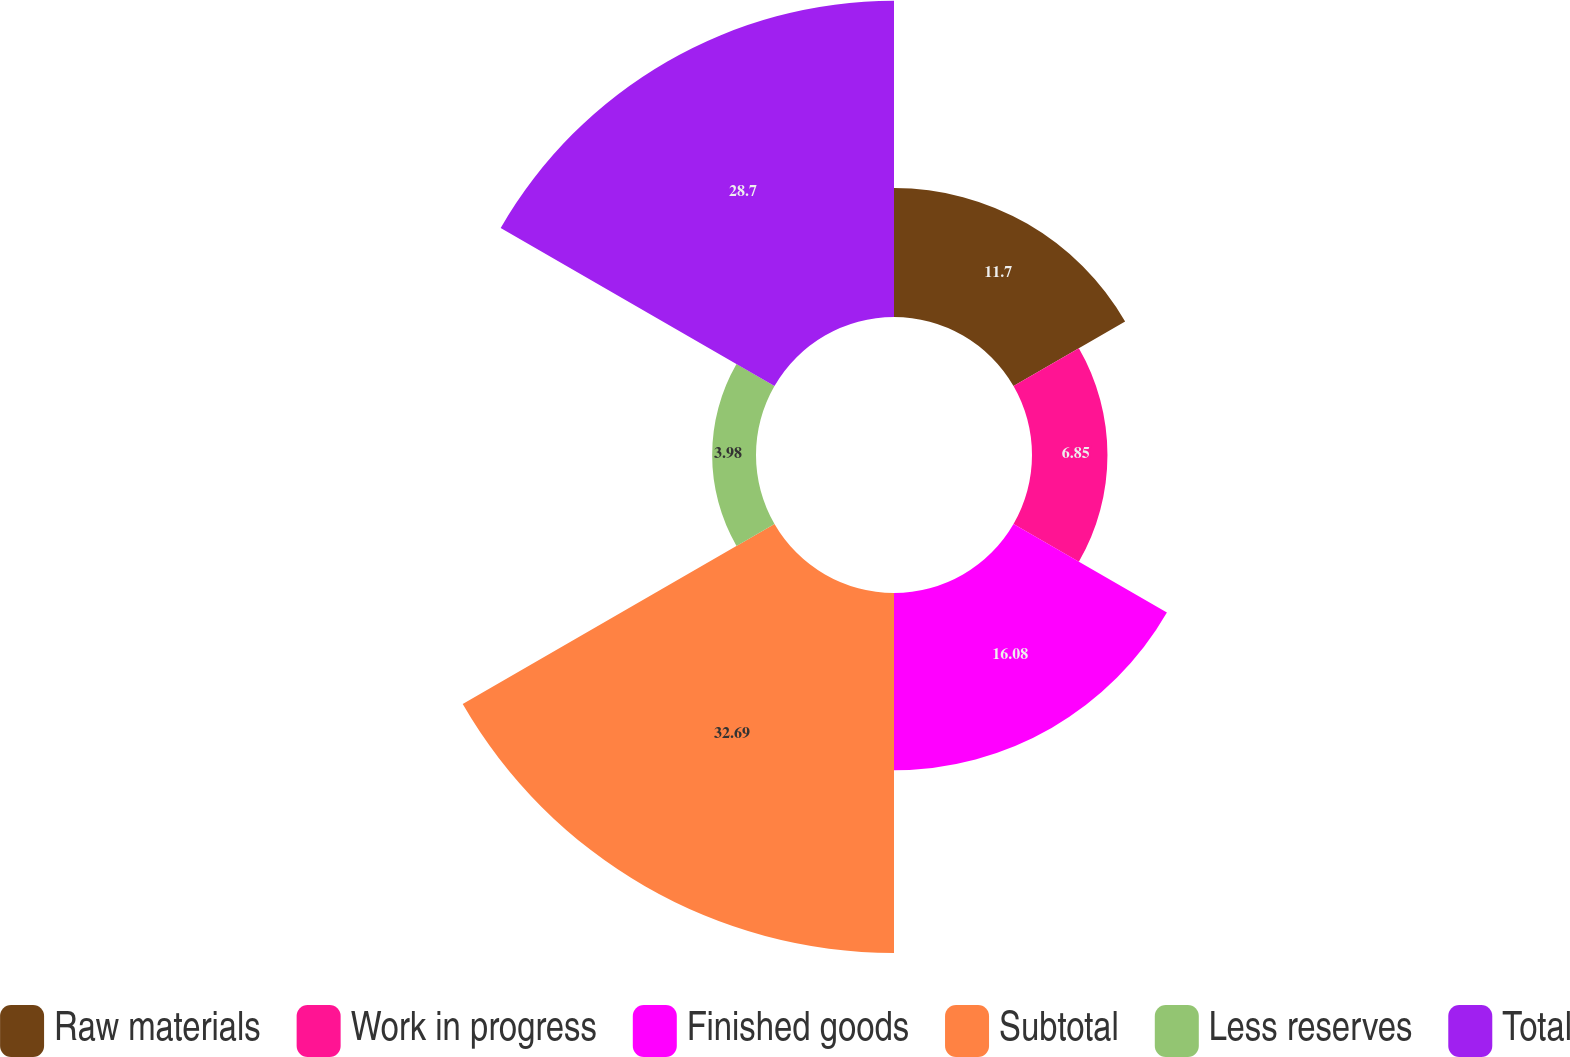Convert chart. <chart><loc_0><loc_0><loc_500><loc_500><pie_chart><fcel>Raw materials<fcel>Work in progress<fcel>Finished goods<fcel>Subtotal<fcel>Less reserves<fcel>Total<nl><fcel>11.7%<fcel>6.85%<fcel>16.08%<fcel>32.68%<fcel>3.98%<fcel>28.7%<nl></chart> 